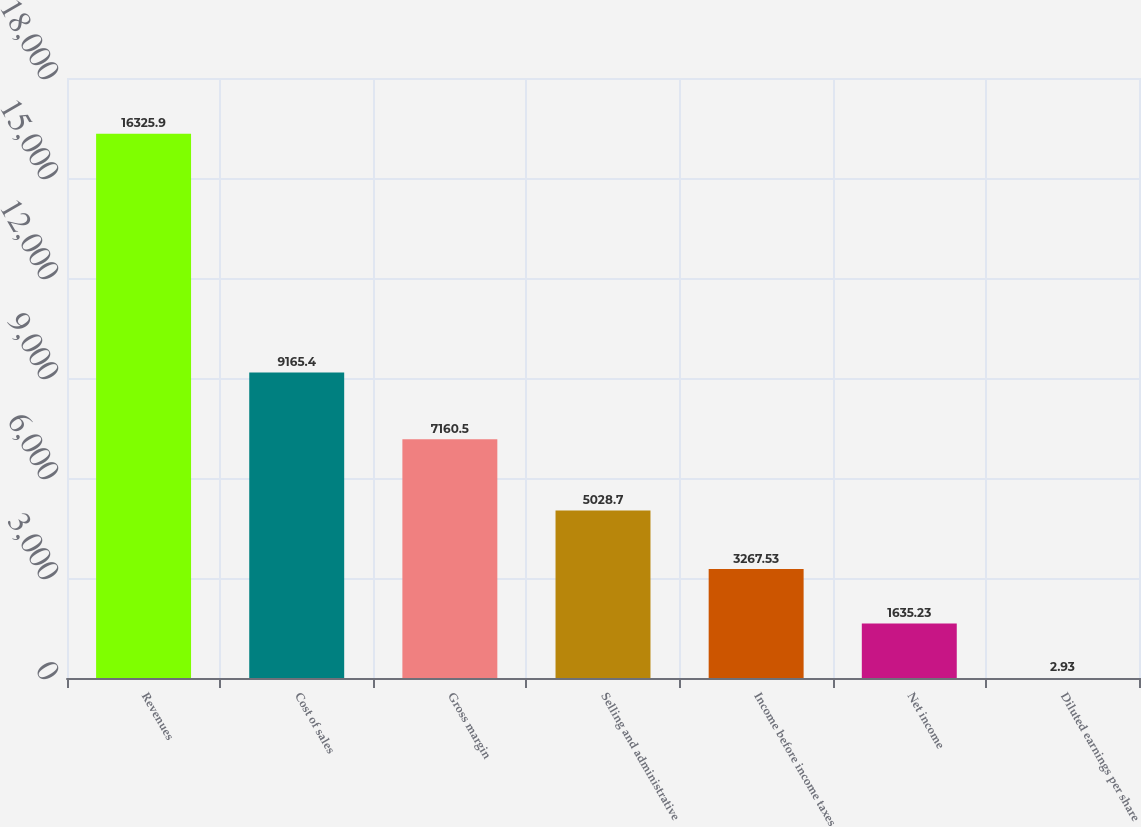Convert chart. <chart><loc_0><loc_0><loc_500><loc_500><bar_chart><fcel>Revenues<fcel>Cost of sales<fcel>Gross margin<fcel>Selling and administrative<fcel>Income before income taxes<fcel>Net income<fcel>Diluted earnings per share<nl><fcel>16325.9<fcel>9165.4<fcel>7160.5<fcel>5028.7<fcel>3267.53<fcel>1635.23<fcel>2.93<nl></chart> 